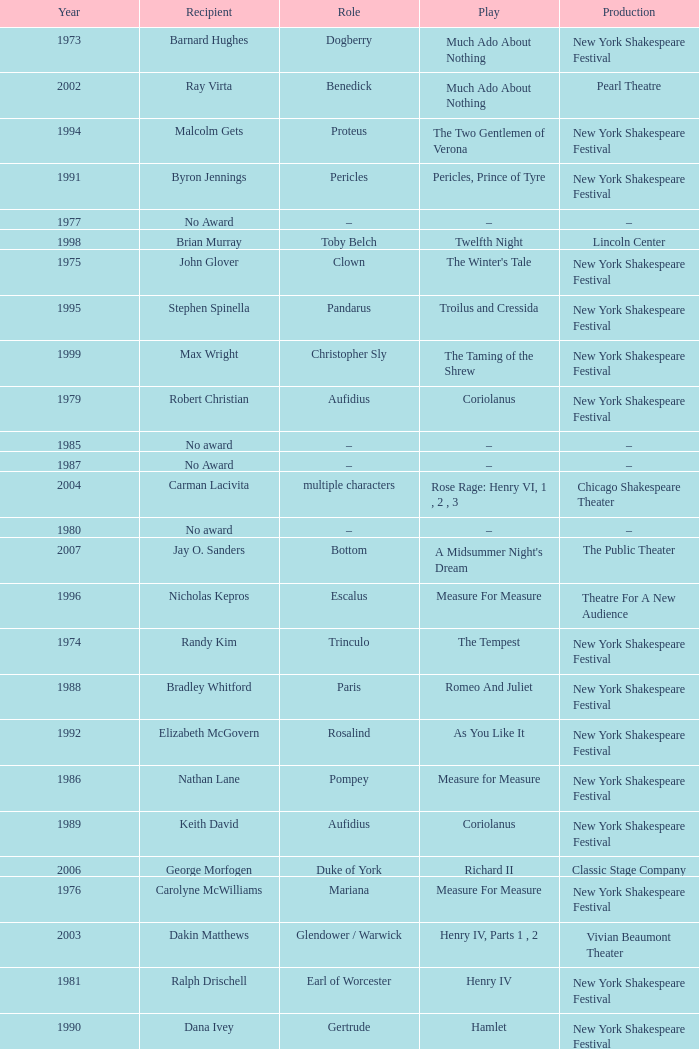Name the recipientof the year for 1976 Carolyne McWilliams. 